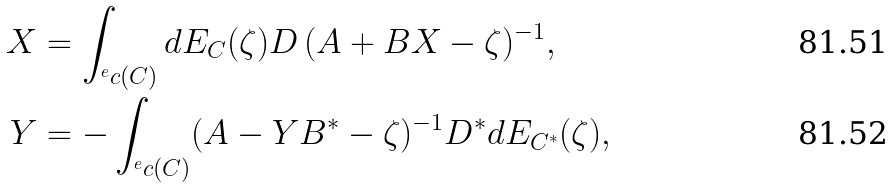Convert formula to latex. <formula><loc_0><loc_0><loc_500><loc_500>X & = \int _ { ^ { e } c ( C ) } d E _ { C } ( \zeta ) D \, ( A + B X - \zeta ) ^ { - 1 } , \\ Y & = - \int _ { ^ { e } c ( C ) } ( A - Y B ^ { * } - \zeta ) ^ { - 1 } D ^ { * } d E _ { C ^ { * } } ( \zeta ) ,</formula> 